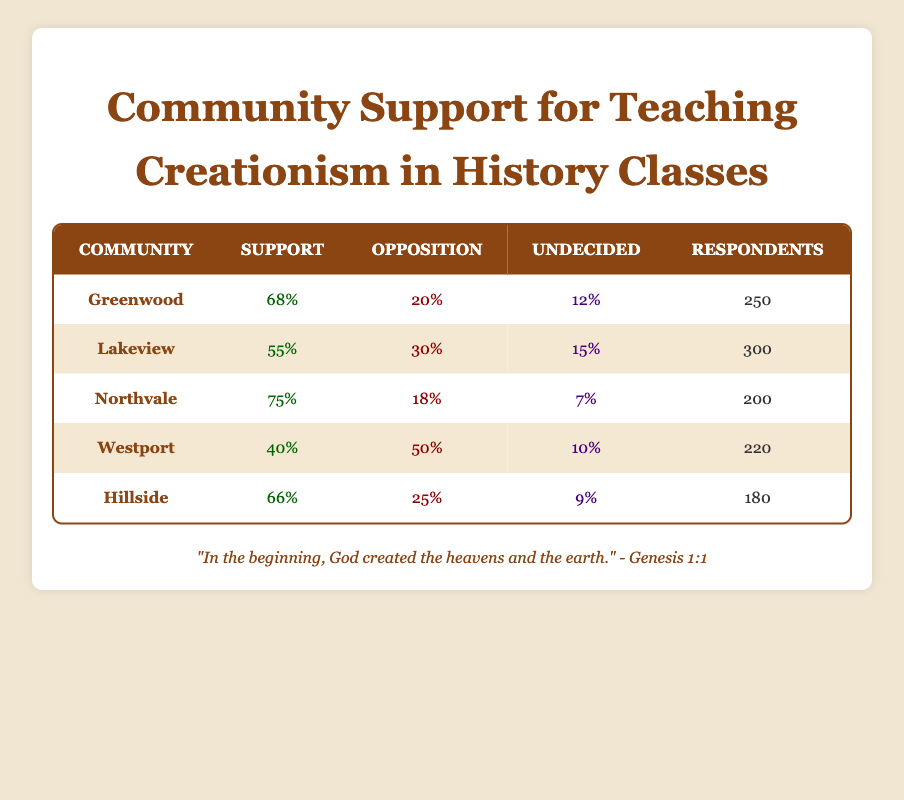What community has the highest percentage of support for teaching creationism? Looking at the support percentages listed in the table, Northvale has the highest percentage at 75%.
Answer: Northvale How many respondents opposed teaching creationism in Westport? The table shows that 50% of respondents in Westport opposed teaching creationism. Given that there are 220 respondents in total, the number of respondents who opposed is calculated as 50% of 220, which equals 110.
Answer: 110 Is the overall support for teaching creationism greater than the overall opposition across all communities? To find this, we need to calculate the total support and total opposition. The total supporters are (68 + 55 + 75 + 40 + 66) = 304, and the total opposers are (20 + 30 + 18 + 50 + 25) = 143. Since 304 is greater than 143, the statement is true.
Answer: Yes What is the average percentage of respondents supporting teaching creationism across all communities? To find the average, add the support percentages: (68 + 55 + 75 + 40 + 66) = 304. Then, divide by the number of communities, which is 5. So, the average support percentage is 304/5 = 60.8%.
Answer: 60.8% What percentage of respondents in Lakeview were undecided about teaching creationism? The table indicates that 15% of respondents in Lakeview were undecided, as shown directly in the respective column.
Answer: 15% Which community has the least support for teaching creationism, and what is the percentage? By reviewing the support percentages, Westport has the least support at only 40%.
Answer: Westport, 40% 